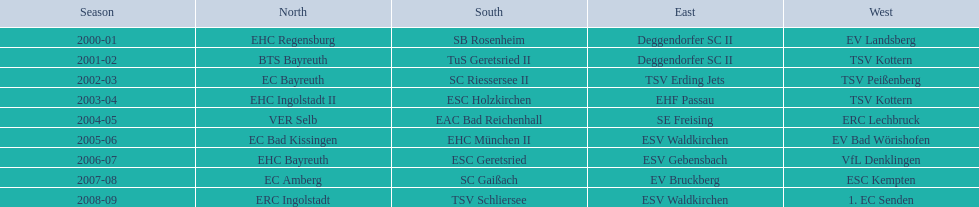The only team to win the north in 2000-01 season? EHC Regensburg. 